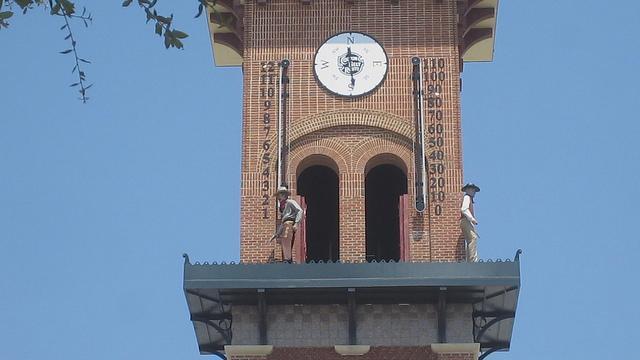What is the device shown in the image?
From the following set of four choices, select the accurate answer to respond to the question.
Options: Compass, painting, clock, photography. Compass. 